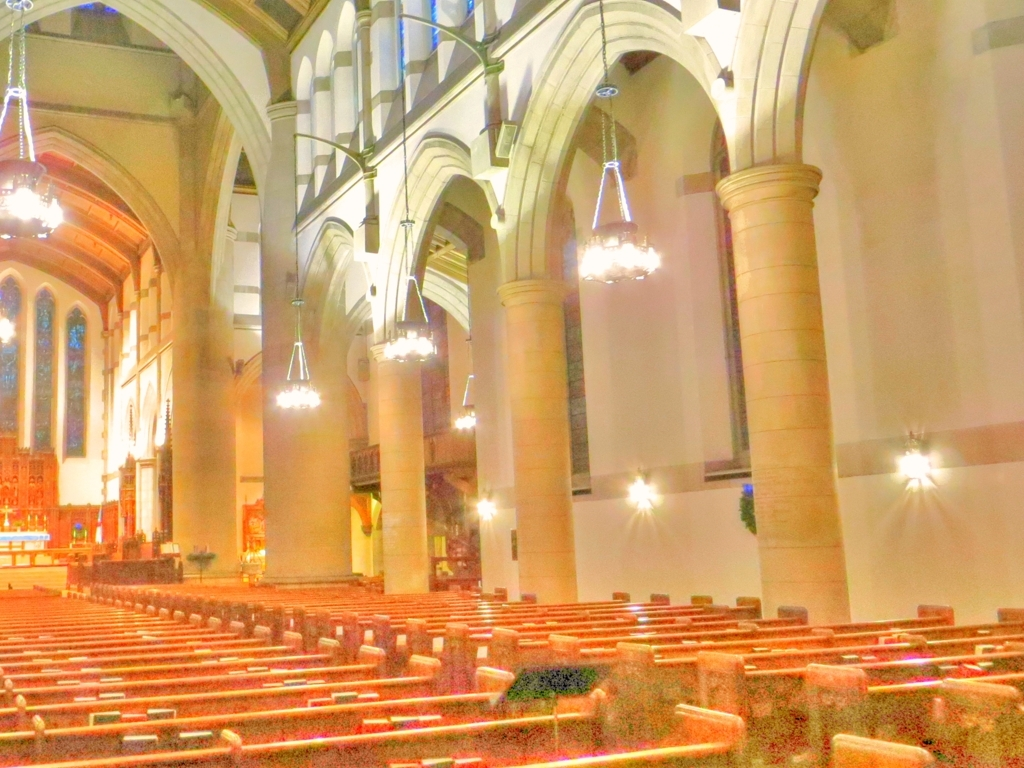What mood does the lighting in the picture evoke? The lighting in the image gives off a warm and inviting atmosphere, with the gentle illumination of the chandeliers and the soft glow on the walls conveying a sense of calm and reverence suitable for a spiritual or contemplative setting. The light appears to accentuate the architectural features, creating an ambient and serene mood. 